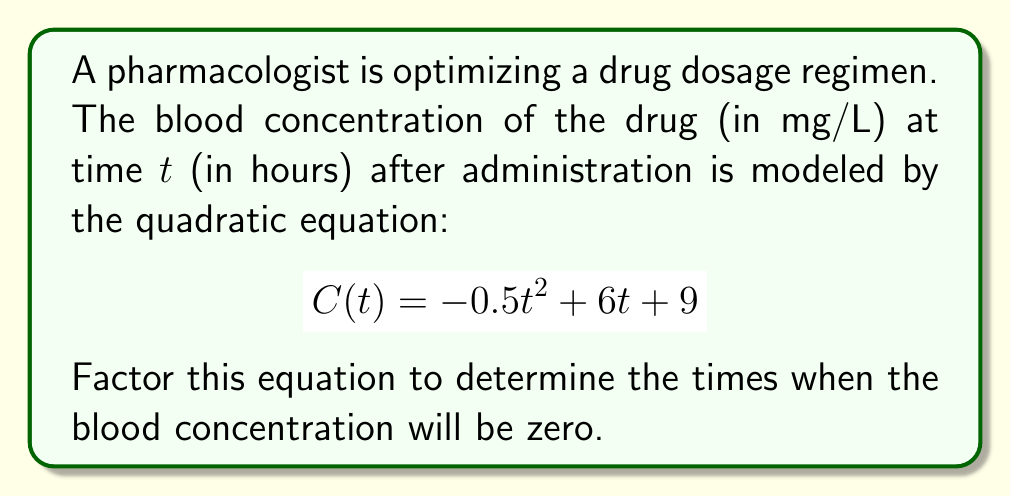Solve this math problem. To factor this quadratic equation, we'll follow these steps:

1) First, identify the coefficients:
   $a = -0.5$, $b = 6$, and $c = 9$

2) We need to find two numbers that multiply to give $ac$ and add to give $b$:
   $ac = (-0.5)(9) = -4.5$
   We need two numbers that multiply to -4.5 and add to 6.
   These numbers are 6.5 and -0.5

3) Rewrite the middle term using these numbers:
   $$C(t) = -0.5t^2 + 6.5t - 0.5t + 9$$

4) Group the terms:
   $$C(t) = (-0.5t^2 + 6.5t) + (-0.5t + 9)$$

5) Factor out the common factor from each group:
   $$C(t) = -0.5t(t - 13) - 1(0.5t - 9)$$

6) Factor out $-(0.5t - 9)$:
   $$C(t) = -(0.5t - 9)(t - 13)$$

7) Set $C(t) = 0$ and solve:
   $$0 = -(0.5t - 9)(t - 13)$$
   
   Either $0.5t - 9 = 0$ or $t - 13 = 0$
   
   $t = 18$ or $t = 13$

Therefore, the blood concentration will be zero at 13 hours and 18 hours after administration.
Answer: The factored equation is: $$C(t) = -(0.5t - 9)(t - 13)$$
The blood concentration will be zero at $t = 13$ hours and $t = 18$ hours. 